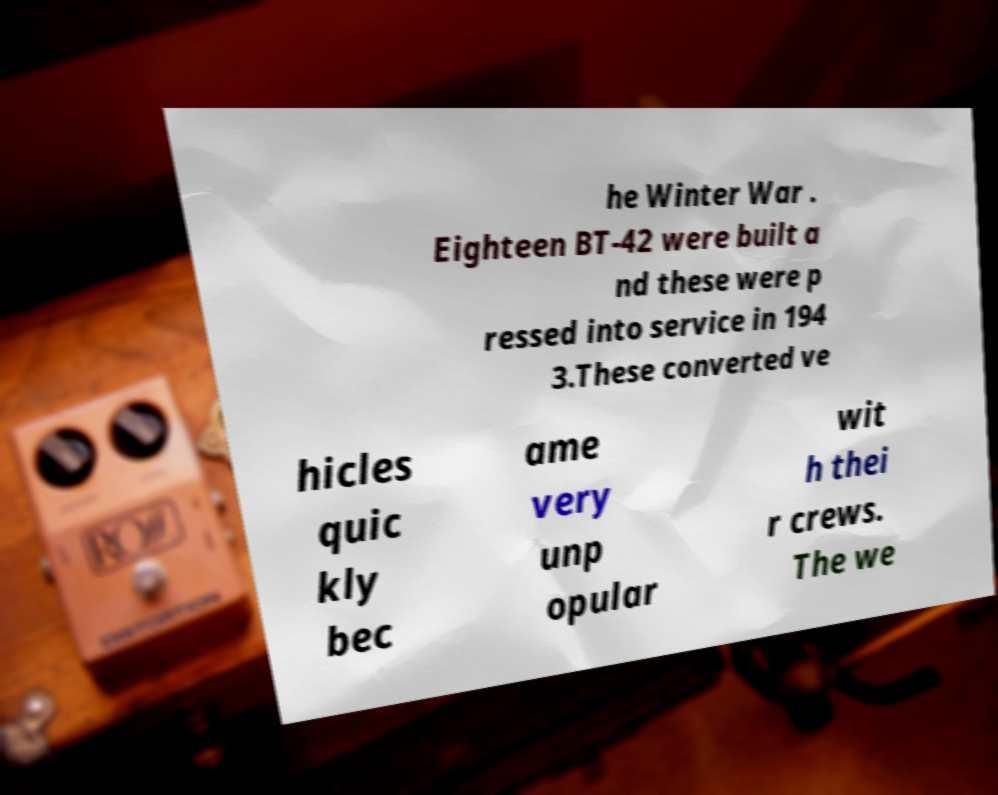Could you extract and type out the text from this image? he Winter War . Eighteen BT-42 were built a nd these were p ressed into service in 194 3.These converted ve hicles quic kly bec ame very unp opular wit h thei r crews. The we 